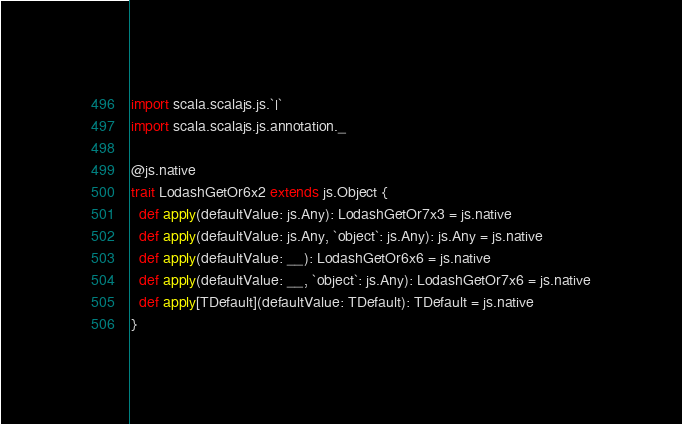<code> <loc_0><loc_0><loc_500><loc_500><_Scala_>import scala.scalajs.js.`|`
import scala.scalajs.js.annotation._

@js.native
trait LodashGetOr6x2 extends js.Object {
  def apply(defaultValue: js.Any): LodashGetOr7x3 = js.native
  def apply(defaultValue: js.Any, `object`: js.Any): js.Any = js.native
  def apply(defaultValue: __): LodashGetOr6x6 = js.native
  def apply(defaultValue: __, `object`: js.Any): LodashGetOr7x6 = js.native
  def apply[TDefault](defaultValue: TDefault): TDefault = js.native
}

</code> 